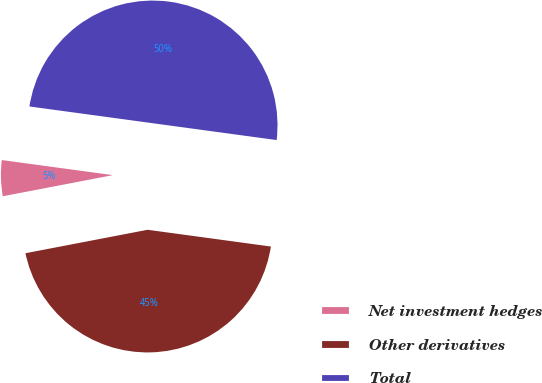Convert chart to OTSL. <chart><loc_0><loc_0><loc_500><loc_500><pie_chart><fcel>Net investment hedges<fcel>Other derivatives<fcel>Total<nl><fcel>5.17%<fcel>44.83%<fcel>50.0%<nl></chart> 